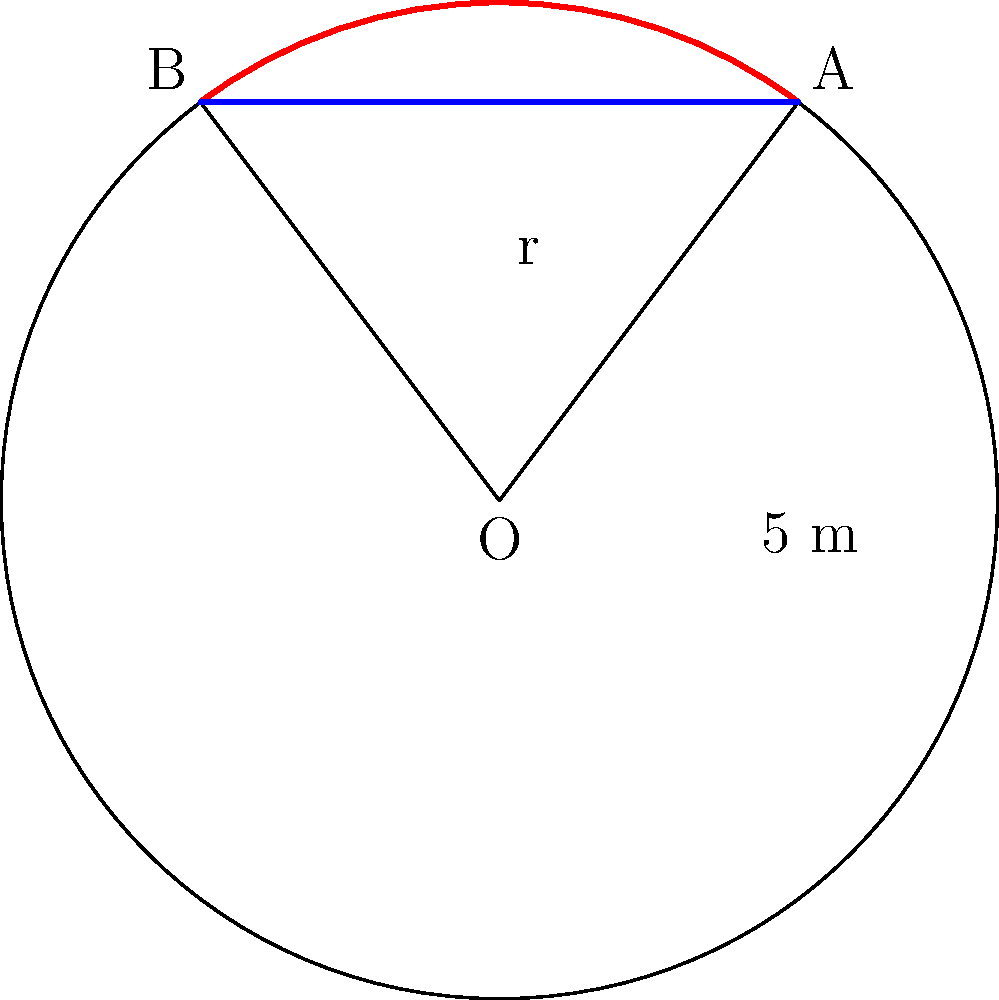In the "La casa de papel" heist, the team needs to dig a circular tunnel into the bank. The tunnel's cross-section forms a circular segment as shown in the diagram. If the radius of the circular cross-section is 5 meters and the chord AB is 6 meters long, what is the area of the circular segment (shaded region) in square meters? Round your answer to two decimal places. Let's solve this step-by-step:

1) First, we need to find the central angle $\theta$ (in radians) that corresponds to the circular segment.

2) We can use the formula: $\cos(\theta/2) = \frac{\text{chord length}}{2r}$

   $\cos(\theta/2) = \frac{6}{2(5)} = \frac{3}{5}$

3) Therefore, $\theta/2 = \arccos(\frac{3}{5})$
   
   $\theta = 2\arccos(\frac{3}{5})$

4) The area of a circular segment is given by the formula:
   
   $A = r^2(\theta - \sin\theta)$

5) Substituting our values:

   $A = 5^2(2\arccos(\frac{3}{5}) - \sin(2\arccos(\frac{3}{5})))$

6) Simplify:
   
   $A = 25(2\arccos(\frac{3}{5}) - \sin(2\arccos(\frac{3}{5})))$

7) Calculate (using a calculator):
   
   $A \approx 25(2.2143 - 0.6435) \approx 39.27$ sq meters

8) Rounding to two decimal places:
   
   $A \approx 39.27$ sq meters
Answer: 39.27 sq meters 